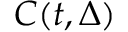<formula> <loc_0><loc_0><loc_500><loc_500>C ( t , \Delta )</formula> 